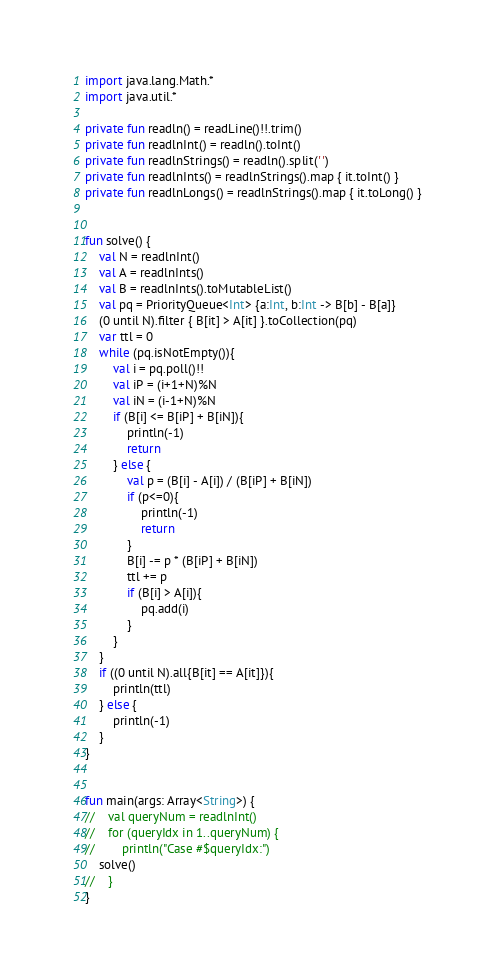Convert code to text. <code><loc_0><loc_0><loc_500><loc_500><_Kotlin_>import java.lang.Math.*
import java.util.*

private fun readln() = readLine()!!.trim()
private fun readlnInt() = readln().toInt()
private fun readlnStrings() = readln().split(' ')
private fun readlnInts() = readlnStrings().map { it.toInt() }
private fun readlnLongs() = readlnStrings().map { it.toLong() }


fun solve() {
    val N = readlnInt()
    val A = readlnInts()
    val B = readlnInts().toMutableList()
    val pq = PriorityQueue<Int> {a:Int, b:Int -> B[b] - B[a]}
    (0 until N).filter { B[it] > A[it] }.toCollection(pq)
    var ttl = 0
    while (pq.isNotEmpty()){
        val i = pq.poll()!!
        val iP = (i+1+N)%N
        val iN = (i-1+N)%N
        if (B[i] <= B[iP] + B[iN]){
            println(-1)
            return
        } else {
            val p = (B[i] - A[i]) / (B[iP] + B[iN])
            if (p<=0){
                println(-1)
                return
            }
            B[i] -= p * (B[iP] + B[iN])
            ttl += p
            if (B[i] > A[i]){
                pq.add(i)
            }
        }
    }
    if ((0 until N).all{B[it] == A[it]}){
        println(ttl)
    } else {
        println(-1)
    }
}


fun main(args: Array<String>) {
//    val queryNum = readlnInt()
//    for (queryIdx in 1..queryNum) {
//        println("Case #$queryIdx:")
    solve()
//    }
}
</code> 